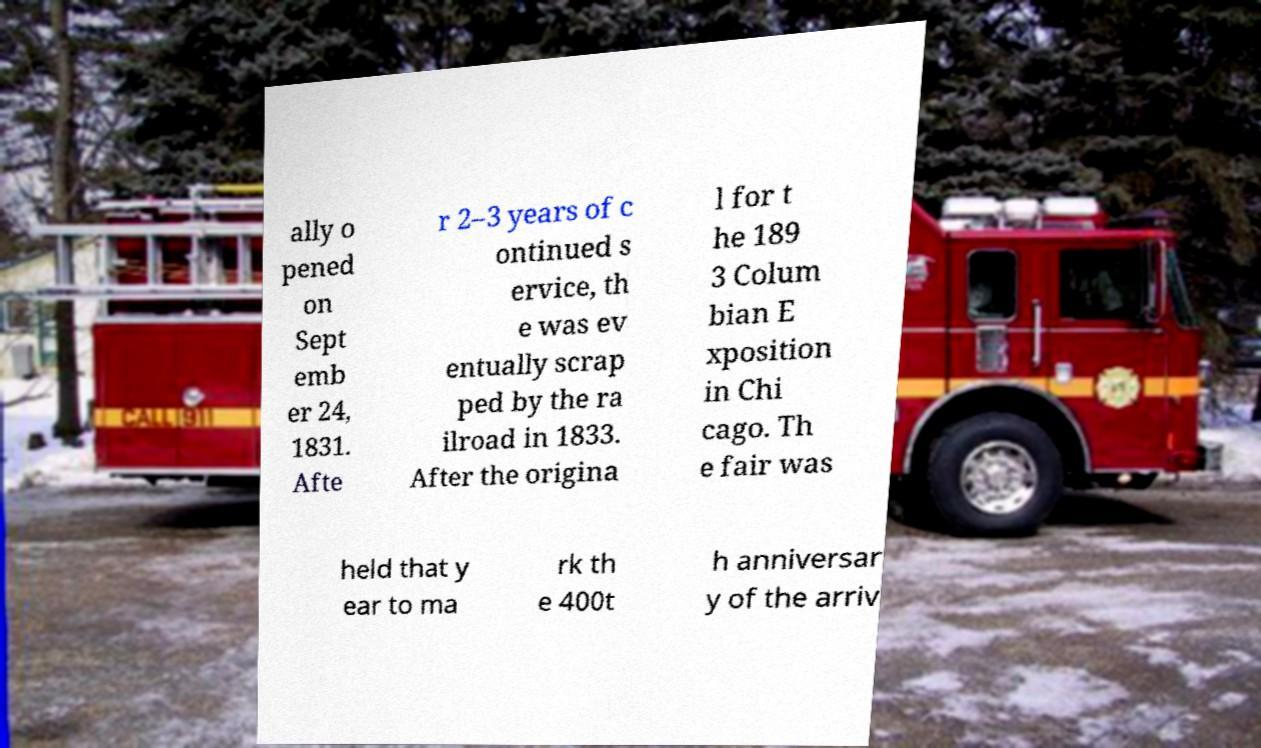I need the written content from this picture converted into text. Can you do that? ally o pened on Sept emb er 24, 1831. Afte r 2–3 years of c ontinued s ervice, th e was ev entually scrap ped by the ra ilroad in 1833. After the origina l for t he 189 3 Colum bian E xposition in Chi cago. Th e fair was held that y ear to ma rk th e 400t h anniversar y of the arriv 